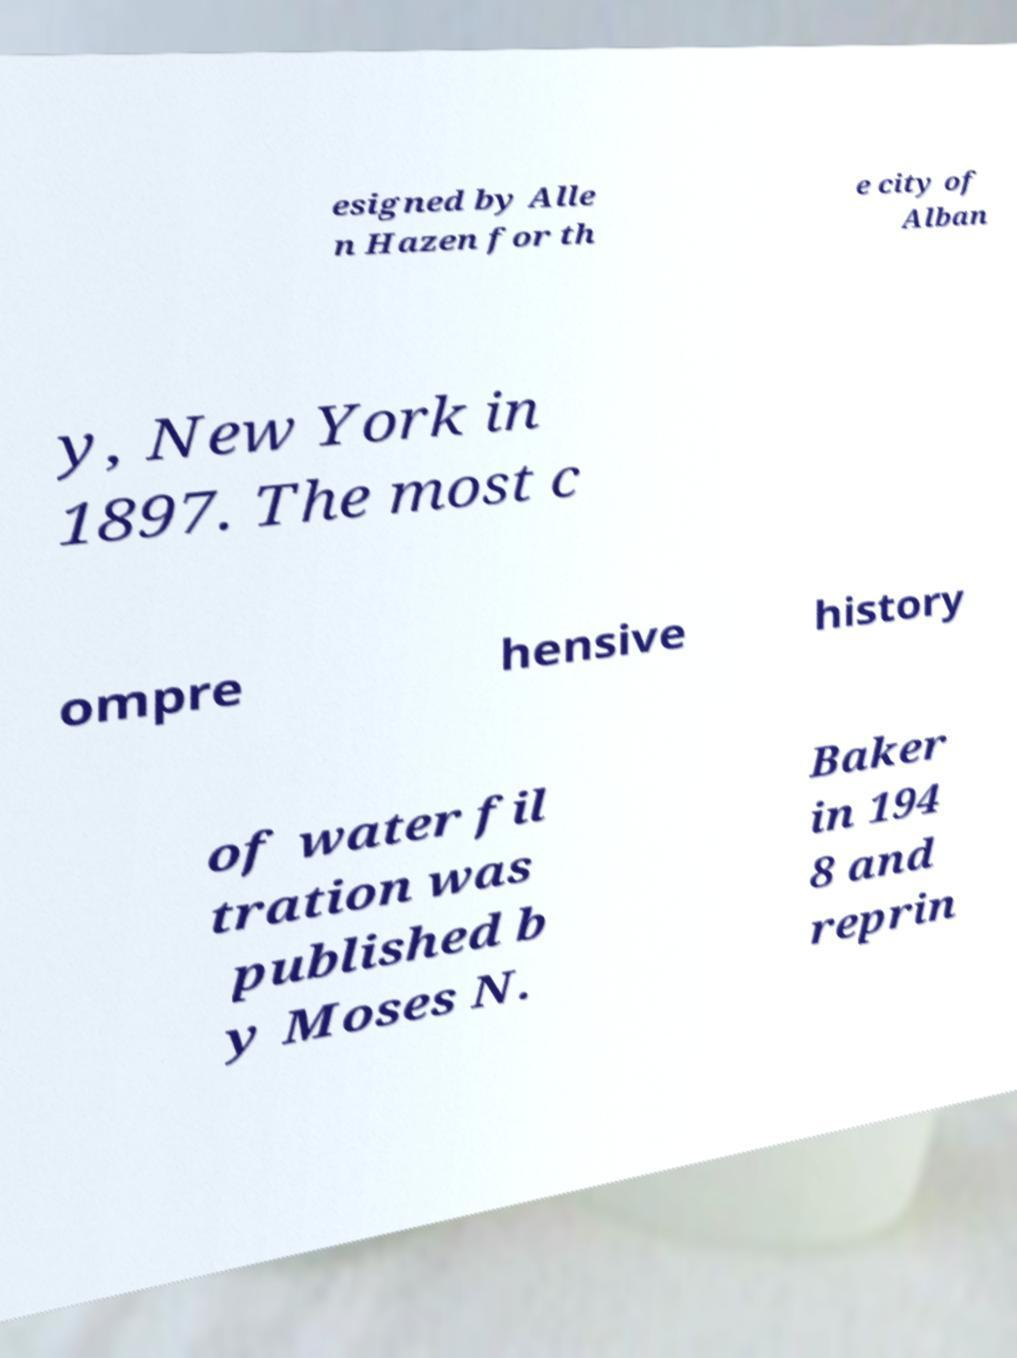Can you read and provide the text displayed in the image?This photo seems to have some interesting text. Can you extract and type it out for me? esigned by Alle n Hazen for th e city of Alban y, New York in 1897. The most c ompre hensive history of water fil tration was published b y Moses N. Baker in 194 8 and reprin 